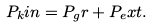Convert formula to latex. <formula><loc_0><loc_0><loc_500><loc_500>P _ { k } i n = P _ { g } r + P _ { e } x t .</formula> 